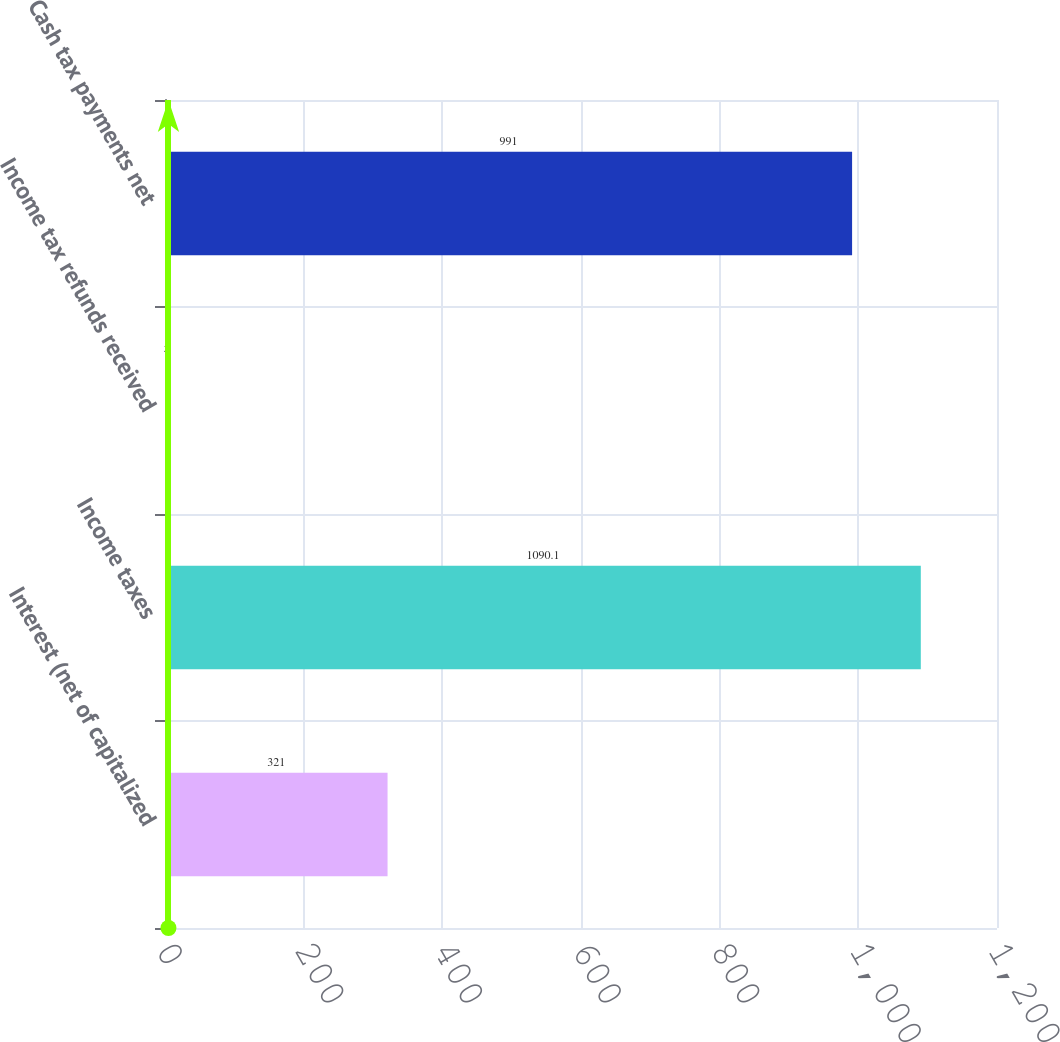Convert chart to OTSL. <chart><loc_0><loc_0><loc_500><loc_500><bar_chart><fcel>Interest (net of capitalized<fcel>Income taxes<fcel>Income tax refunds received<fcel>Cash tax payments net<nl><fcel>321<fcel>1090.1<fcel>5<fcel>991<nl></chart> 